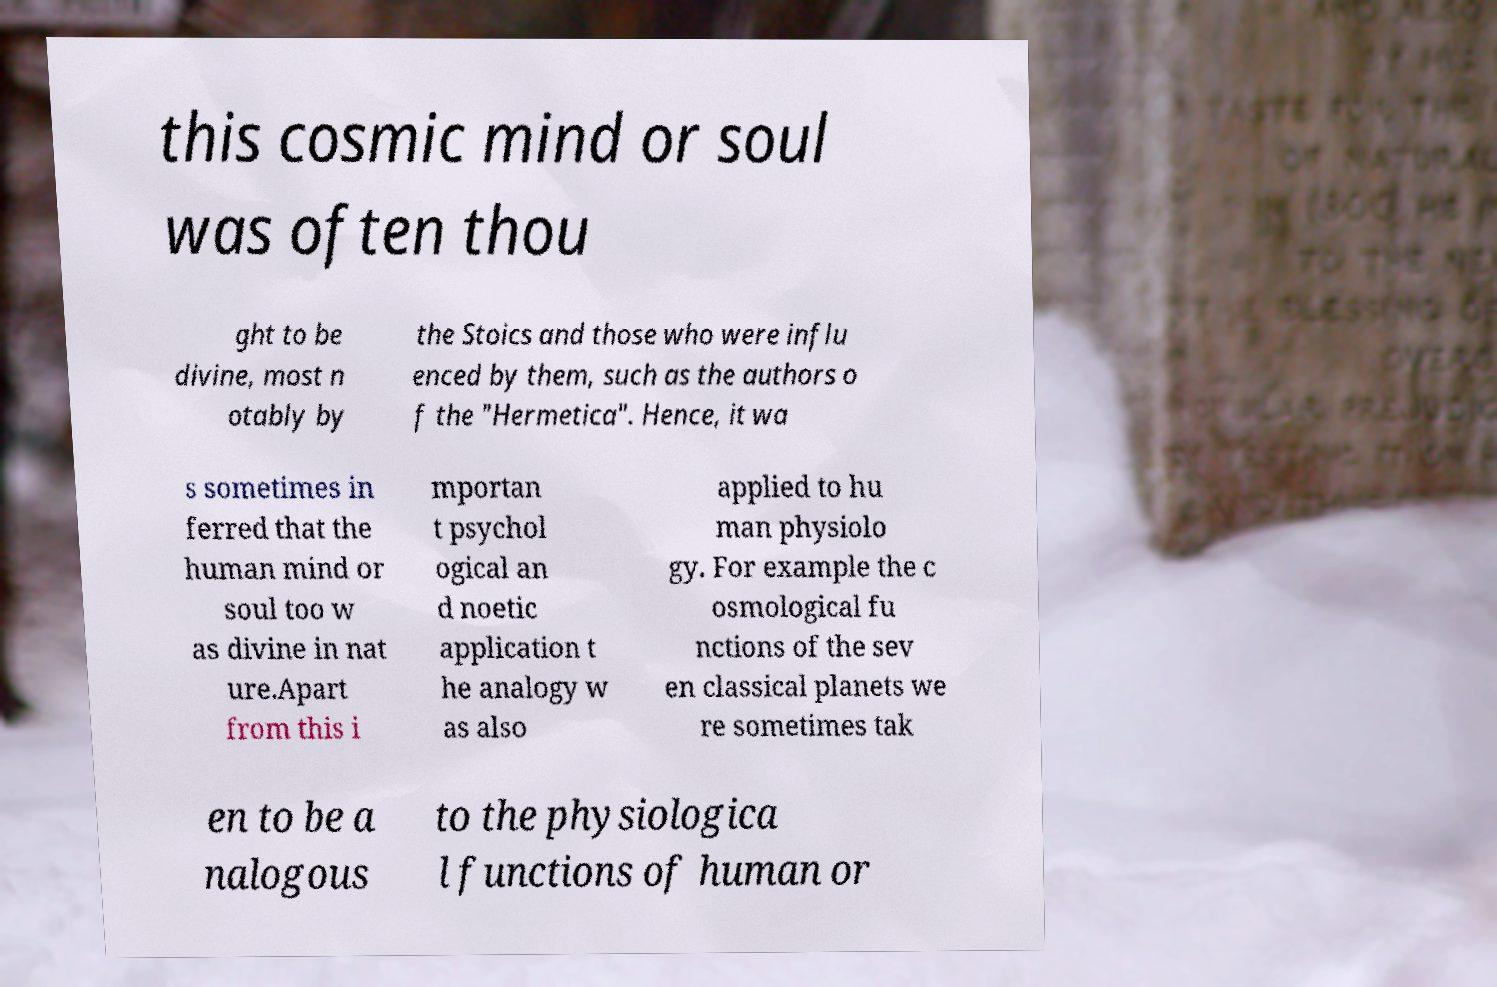Please identify and transcribe the text found in this image. this cosmic mind or soul was often thou ght to be divine, most n otably by the Stoics and those who were influ enced by them, such as the authors o f the "Hermetica". Hence, it wa s sometimes in ferred that the human mind or soul too w as divine in nat ure.Apart from this i mportan t psychol ogical an d noetic application t he analogy w as also applied to hu man physiolo gy. For example the c osmological fu nctions of the sev en classical planets we re sometimes tak en to be a nalogous to the physiologica l functions of human or 